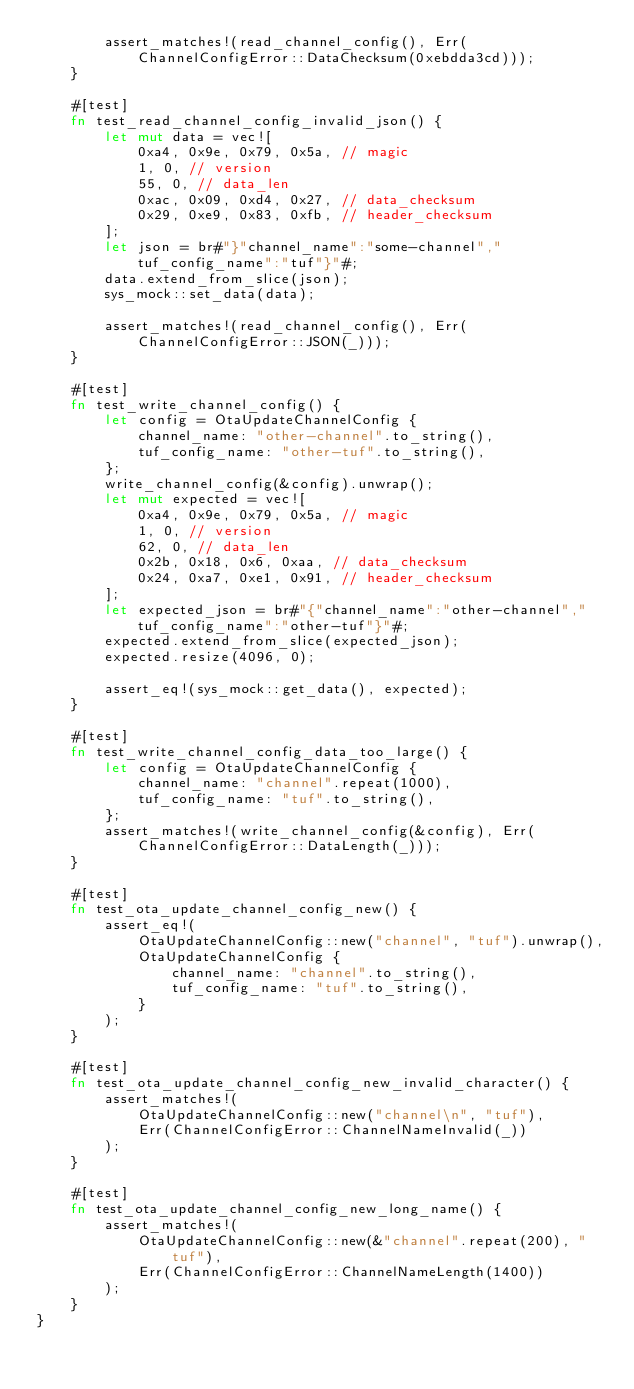Convert code to text. <code><loc_0><loc_0><loc_500><loc_500><_Rust_>        assert_matches!(read_channel_config(), Err(ChannelConfigError::DataChecksum(0xebdda3cd)));
    }

    #[test]
    fn test_read_channel_config_invalid_json() {
        let mut data = vec![
            0xa4, 0x9e, 0x79, 0x5a, // magic
            1, 0, // version
            55, 0, // data_len
            0xac, 0x09, 0xd4, 0x27, // data_checksum
            0x29, 0xe9, 0x83, 0xfb, // header_checksum
        ];
        let json = br#"}"channel_name":"some-channel","tuf_config_name":"tuf"}"#;
        data.extend_from_slice(json);
        sys_mock::set_data(data);

        assert_matches!(read_channel_config(), Err(ChannelConfigError::JSON(_)));
    }

    #[test]
    fn test_write_channel_config() {
        let config = OtaUpdateChannelConfig {
            channel_name: "other-channel".to_string(),
            tuf_config_name: "other-tuf".to_string(),
        };
        write_channel_config(&config).unwrap();
        let mut expected = vec![
            0xa4, 0x9e, 0x79, 0x5a, // magic
            1, 0, // version
            62, 0, // data_len
            0x2b, 0x18, 0x6, 0xaa, // data_checksum
            0x24, 0xa7, 0xe1, 0x91, // header_checksum
        ];
        let expected_json = br#"{"channel_name":"other-channel","tuf_config_name":"other-tuf"}"#;
        expected.extend_from_slice(expected_json);
        expected.resize(4096, 0);

        assert_eq!(sys_mock::get_data(), expected);
    }

    #[test]
    fn test_write_channel_config_data_too_large() {
        let config = OtaUpdateChannelConfig {
            channel_name: "channel".repeat(1000),
            tuf_config_name: "tuf".to_string(),
        };
        assert_matches!(write_channel_config(&config), Err(ChannelConfigError::DataLength(_)));
    }

    #[test]
    fn test_ota_update_channel_config_new() {
        assert_eq!(
            OtaUpdateChannelConfig::new("channel", "tuf").unwrap(),
            OtaUpdateChannelConfig {
                channel_name: "channel".to_string(),
                tuf_config_name: "tuf".to_string(),
            }
        );
    }

    #[test]
    fn test_ota_update_channel_config_new_invalid_character() {
        assert_matches!(
            OtaUpdateChannelConfig::new("channel\n", "tuf"),
            Err(ChannelConfigError::ChannelNameInvalid(_))
        );
    }

    #[test]
    fn test_ota_update_channel_config_new_long_name() {
        assert_matches!(
            OtaUpdateChannelConfig::new(&"channel".repeat(200), "tuf"),
            Err(ChannelConfigError::ChannelNameLength(1400))
        );
    }
}
</code> 